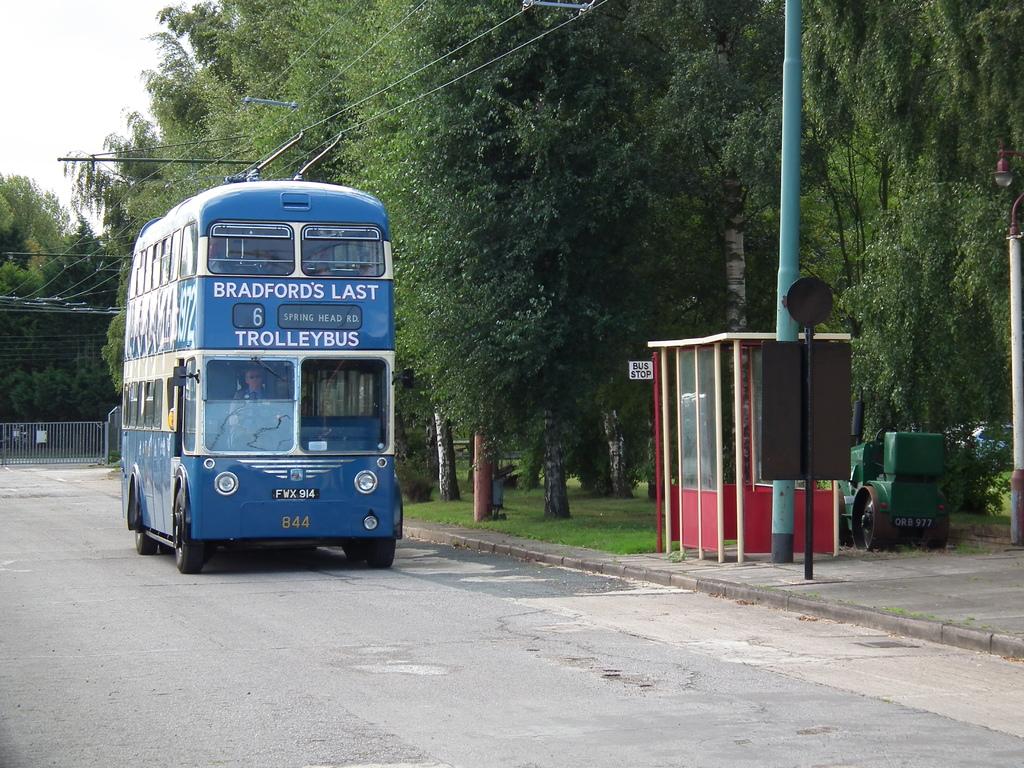What is the bus number?
Give a very brief answer. 6. 